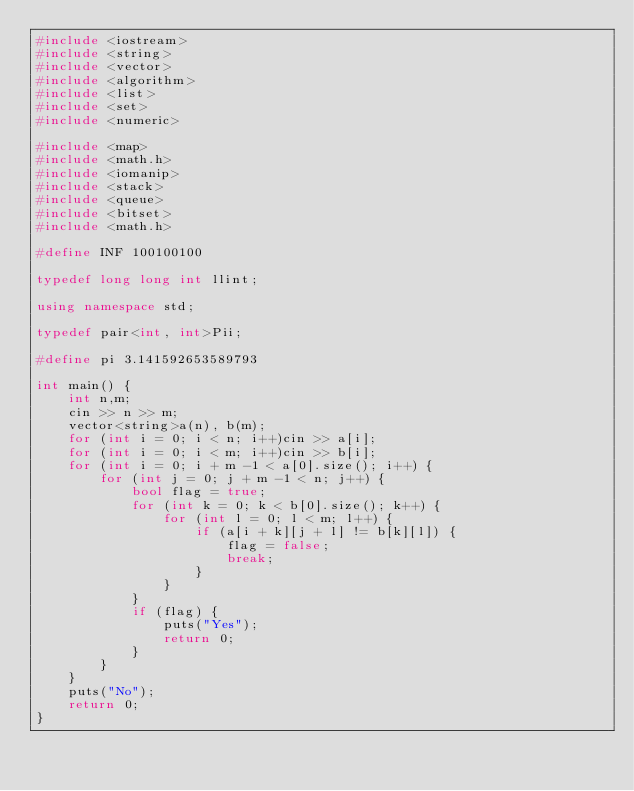<code> <loc_0><loc_0><loc_500><loc_500><_C++_>#include <iostream>
#include <string>
#include <vector>
#include <algorithm>
#include <list>
#include <set>
#include <numeric>

#include <map>
#include <math.h>
#include <iomanip>
#include <stack>
#include <queue>
#include <bitset>
#include <math.h>

#define INF 100100100

typedef long long int llint;

using namespace std;

typedef pair<int, int>Pii;

#define pi 3.141592653589793

int main() {
	int n,m;
	cin >> n >> m;
	vector<string>a(n), b(m);
	for (int i = 0; i < n; i++)cin >> a[i];
	for (int i = 0; i < m; i++)cin >> b[i];
	for (int i = 0; i + m -1 < a[0].size(); i++) {
		for (int j = 0; j + m -1 < n; j++) {
			bool flag = true;
			for (int k = 0; k < b[0].size(); k++) {
				for (int l = 0; l < m; l++) {
					if (a[i + k][j + l] != b[k][l]) {
						flag = false;
						break;
					}
				}
			}
			if (flag) {
				puts("Yes");
				return 0;
			}
		}
	}
	puts("No");
	return 0;
}</code> 